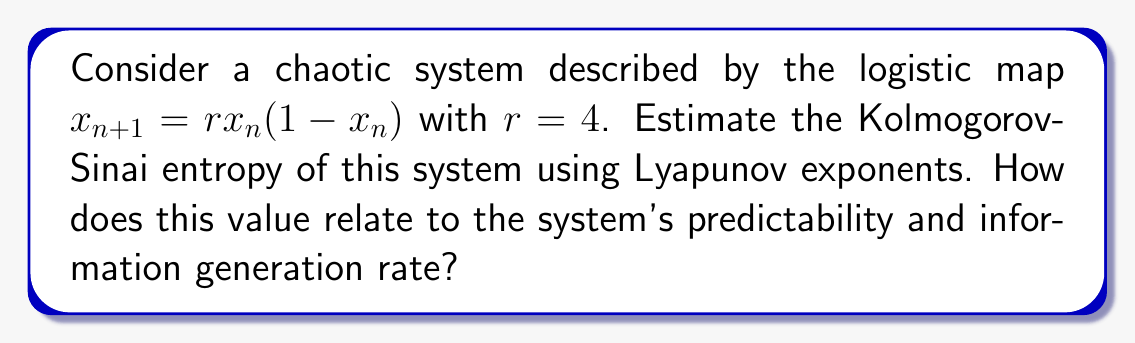Teach me how to tackle this problem. 1. For the logistic map with $r=4$, we first calculate the Lyapunov exponent:

   The Lyapunov exponent $\lambda$ is given by:
   $$\lambda = \lim_{N \to \infty} \frac{1}{N} \sum_{n=0}^{N-1} \ln |f'(x_n)|$$

   For the logistic map, $f'(x) = r(1-2x)$, so $f'(x) = 4(1-2x)$ when $r=4$.

2. For $r=4$, the Lyapunov exponent can be calculated analytically:
   $$\lambda = \ln 2 \approx 0.6931$$

3. For one-dimensional maps, the Kolmogorov-Sinai (KS) entropy is equal to the positive Lyapunov exponent:
   $$h_{KS} = \lambda^+ = \ln 2$$

4. The KS entropy quantifies the rate of information production or the unpredictability of the system:
   - It measures the average rate of creation of new information as the system evolves.
   - Higher KS entropy indicates faster divergence of nearby trajectories and greater chaos.

5. In this case, $h_{KS} = \ln 2 \approx 0.6931$ bits per iteration, meaning:
   - The system generates about 0.6931 bits of new information per iteration.
   - Predictability decreases exponentially with time, with a halving of precision approximately every iteration.

6. This relatively high entropy value indicates:
   - The system is highly chaotic and sensitive to initial conditions.
   - Long-term predictions are practically impossible due to rapid information loss.
   - The system exhibits complex behavior and generates new patterns quickly.
Answer: $h_{KS} = \ln 2 \approx 0.6931$ bits/iteration; high unpredictability and information generation rate. 